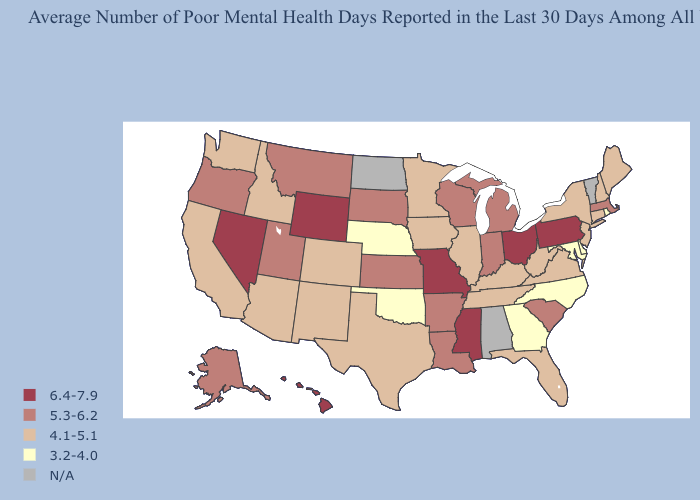Among the states that border North Dakota , does South Dakota have the lowest value?
Keep it brief. No. What is the highest value in the USA?
Short answer required. 6.4-7.9. Among the states that border Connecticut , which have the highest value?
Quick response, please. Massachusetts. What is the value of Connecticut?
Give a very brief answer. 4.1-5.1. What is the value of Georgia?
Be succinct. 3.2-4.0. What is the highest value in the MidWest ?
Keep it brief. 6.4-7.9. How many symbols are there in the legend?
Quick response, please. 5. What is the lowest value in the South?
Be succinct. 3.2-4.0. What is the value of Wyoming?
Be succinct. 6.4-7.9. Does the map have missing data?
Short answer required. Yes. Which states have the highest value in the USA?
Short answer required. Hawaii, Mississippi, Missouri, Nevada, Ohio, Pennsylvania, Wyoming. Among the states that border Colorado , does Wyoming have the highest value?
Concise answer only. Yes. Among the states that border Illinois , which have the lowest value?
Keep it brief. Iowa, Kentucky. Is the legend a continuous bar?
Short answer required. No. 